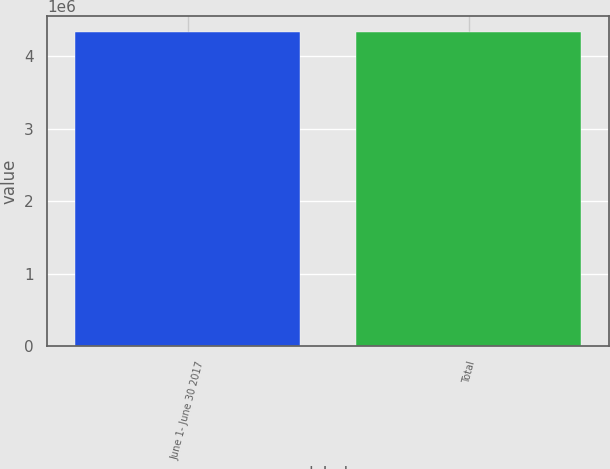Convert chart. <chart><loc_0><loc_0><loc_500><loc_500><bar_chart><fcel>June 1- June 30 2017<fcel>Total<nl><fcel>4.3304e+06<fcel>4.3304e+06<nl></chart> 